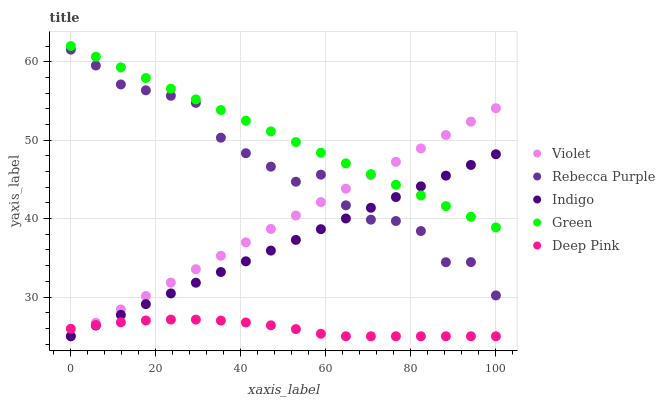Does Deep Pink have the minimum area under the curve?
Answer yes or no. Yes. Does Green have the maximum area under the curve?
Answer yes or no. Yes. Does Indigo have the minimum area under the curve?
Answer yes or no. No. Does Indigo have the maximum area under the curve?
Answer yes or no. No. Is Green the smoothest?
Answer yes or no. Yes. Is Rebecca Purple the roughest?
Answer yes or no. Yes. Is Deep Pink the smoothest?
Answer yes or no. No. Is Deep Pink the roughest?
Answer yes or no. No. Does Deep Pink have the lowest value?
Answer yes or no. Yes. Does Rebecca Purple have the lowest value?
Answer yes or no. No. Does Green have the highest value?
Answer yes or no. Yes. Does Indigo have the highest value?
Answer yes or no. No. Is Deep Pink less than Green?
Answer yes or no. Yes. Is Green greater than Deep Pink?
Answer yes or no. Yes. Does Deep Pink intersect Indigo?
Answer yes or no. Yes. Is Deep Pink less than Indigo?
Answer yes or no. No. Is Deep Pink greater than Indigo?
Answer yes or no. No. Does Deep Pink intersect Green?
Answer yes or no. No. 